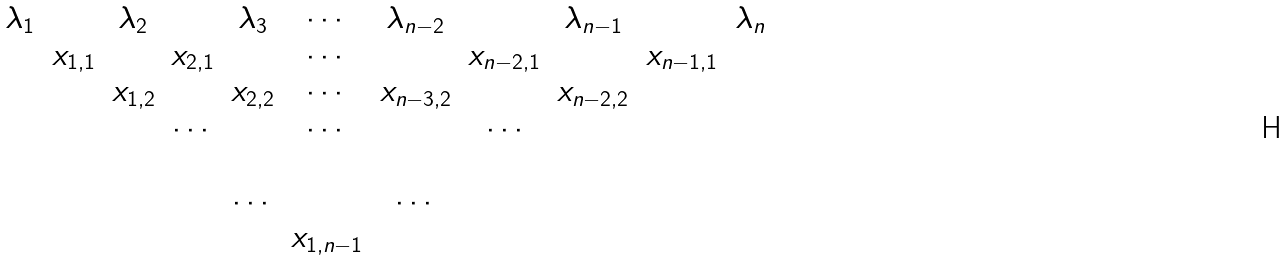<formula> <loc_0><loc_0><loc_500><loc_500>\begin{array} { c c c c c c c c c c c } \lambda _ { 1 } & & \lambda _ { 2 } & & \lambda _ { 3 } & \cdots & \lambda _ { n - 2 } & & \lambda _ { n - 1 } & & \lambda _ { n } \\ & x _ { 1 , 1 } & & x _ { 2 , 1 } & & \cdots & & x _ { n - 2 , 1 } & & x _ { n - 1 , 1 } & \\ & & x _ { 1 , 2 } & & x _ { 2 , 2 } & \cdots & x _ { n - 3 , 2 } & & x _ { n - 2 , 2 } & & \\ & & & \cdots & & \cdots & & \cdots \\ & & & \\ & & & & \cdots & & \cdots & & \\ & & & & & x _ { 1 , n - 1 } & & & & & \\ \end{array}</formula> 